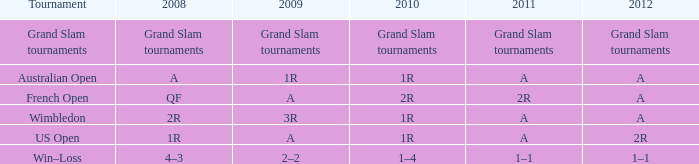Name the 2009 ffor 2010 of 1r and 2012 of a and 2008 of 2r 3R. 